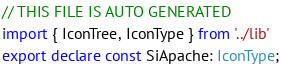Convert code to text. <code><loc_0><loc_0><loc_500><loc_500><_TypeScript_>// THIS FILE IS AUTO GENERATED
import { IconTree, IconType } from '../lib'
export declare const SiApache: IconType;
</code> 